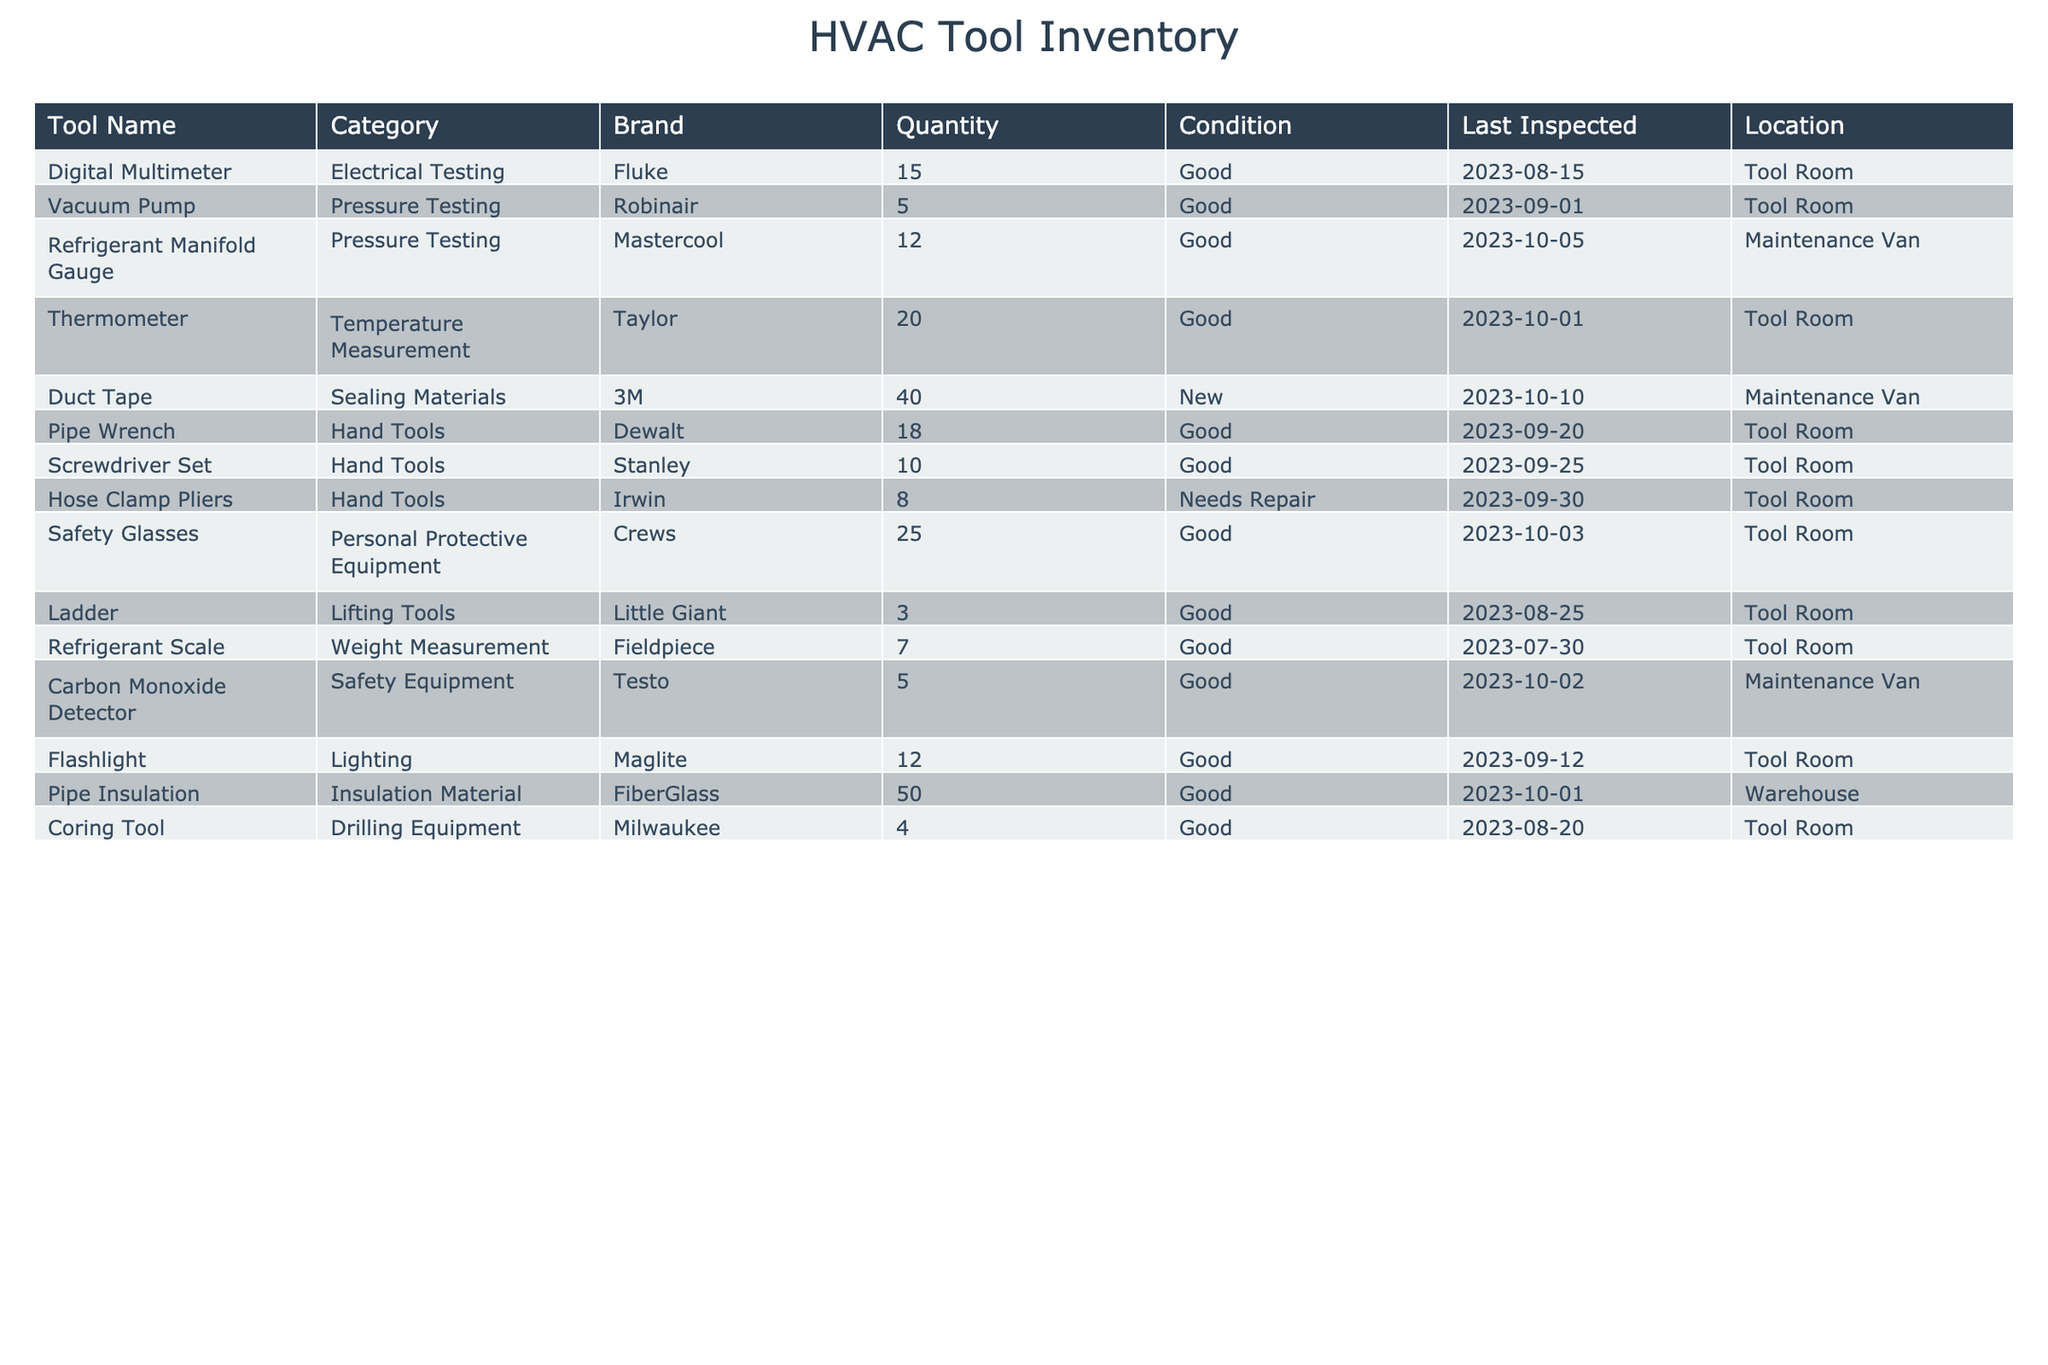What is the quantity of Digital Multimeters in the inventory? The inventory table lists Digital Multimeters under the "Tool Name" column and shows the corresponding quantity in the "Quantity" column. The value for Digital Multimeter is 15.
Answer: 15 How many tools in total are categorized under Hand Tools? To find the total number of Hand Tools, we need to count the quantity from the rows that fall under the "Hand Tools" category. There are three tools: Pipe Wrench (18), Screwdriver Set (10), and Hose Clamp Pliers (8). Adding these gives us a total of 18 + 10 + 8 = 36.
Answer: 36 Is the last inspection of the Vaccum Pump before October 2023? The last inspection date for the Vacuum Pump is listed as 2023-09-01, which is before October 2023. Therefore, this statement is true.
Answer: Yes What brand provides the largest quantity of tools in the inventory? To determine the brand with the largest quantity, we need to observe the quantities for each tool listed in the inventory and find the maximum. The highest quantities are from Taylor (20), 3M (40), and thus, 3M provides the largest quantity with 40.
Answer: 3M How many tools need repair in total? We look for the rows where the condition is stated as "Needs Repair." In the inventory, only the Hose Clamp Pliers are listed with 8 units needing repair. Thus, the total is 8.
Answer: 8 What is the total quantity of tools available for pressure testing? We identify the "Pressure Testing" category and sum the quantities for the Vacuum Pump (5) and Refrigerant Manifold Gauge (12). Therefore, the total quantity is 5 + 12 = 17.
Answer: 17 Are there more types of Personal Protective Equipment than Lifting Tools in the inventory? We can see that there is one type of Personal Protective Equipment (Safety Glasses) and one type of Lifting Tool (Ladder). Since they are equal, the statement is false.
Answer: No What is the average quantity of tools in the Temperature Measurement category? The only tool listed under Temperature Measurement is the Thermometer with a quantity of 20. Since we have only one item, the average is simply 20 / 1 = 20.
Answer: 20 When was the last inspection for all tools categorized as Safety Equipment? In the inventory table, the only tool under the Safety Equipment category is the Carbon Monoxide Detector, last inspected on 2023-10-02. This is the answer as it is the only data point we have for this category.
Answer: 2023-10-02 